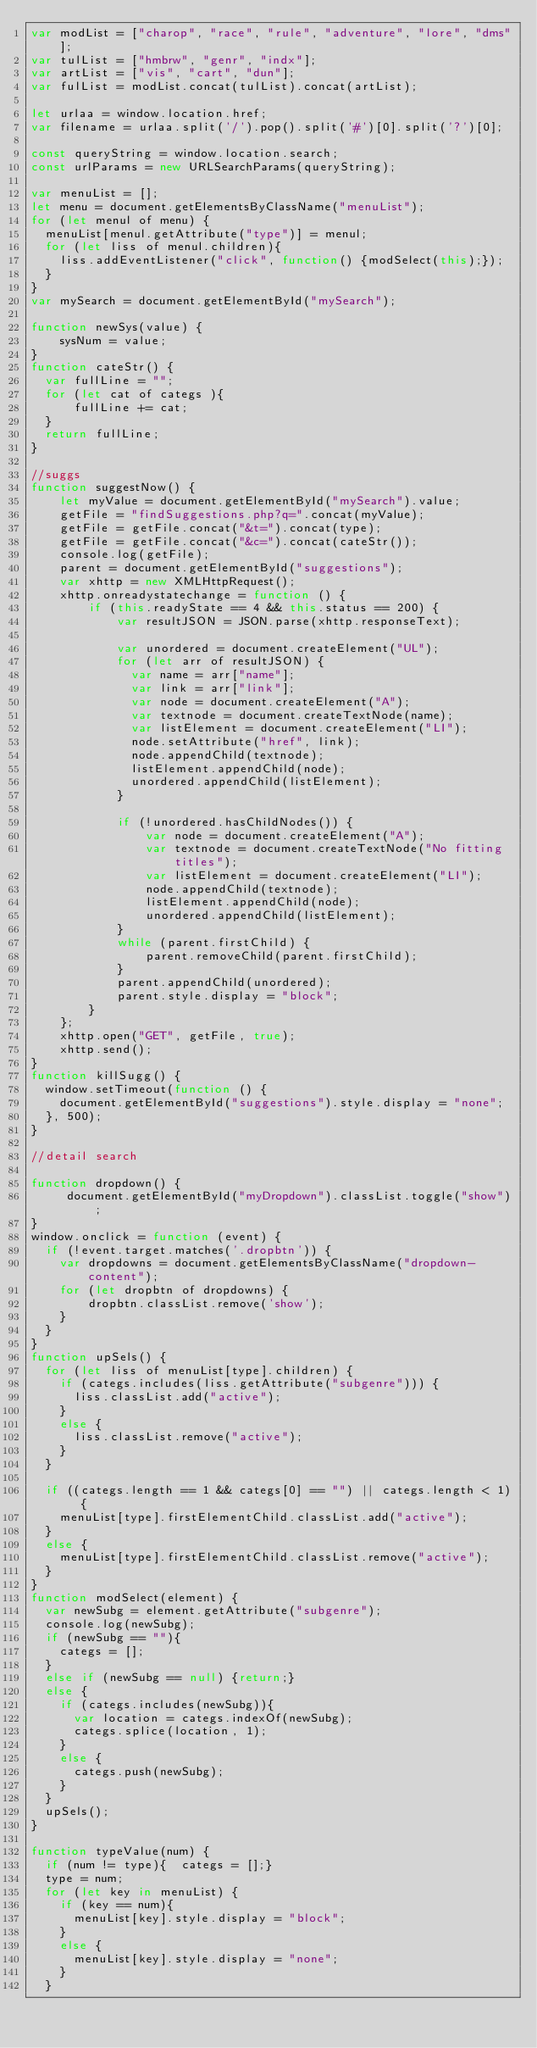<code> <loc_0><loc_0><loc_500><loc_500><_JavaScript_>var modList = ["charop", "race", "rule", "adventure", "lore", "dms"];
var tulList = ["hmbrw", "genr", "indx"];
var artList = ["vis", "cart", "dun"];
var fulList = modList.concat(tulList).concat(artList);

let urlaa = window.location.href;
var filename = urlaa.split('/').pop().split('#')[0].split('?')[0];

const queryString = window.location.search;
const urlParams = new URLSearchParams(queryString);

var menuList = [];
let menu = document.getElementsByClassName("menuList");
for (let menul of menu) {
  menuList[menul.getAttribute("type")] = menul;
  for (let liss of menul.children){
    liss.addEventListener("click", function() {modSelect(this);});
  }
}
var mySearch = document.getElementById("mySearch");

function newSys(value) {
    sysNum = value;
}
function cateStr() {
  var fullLine = "";
  for (let cat of categs ){
      fullLine += cat;
  }
  return fullLine;
}

//suggs
function suggestNow() {
    let myValue = document.getElementById("mySearch").value;
    getFile = "findSuggestions.php?q=".concat(myValue);
    getFile = getFile.concat("&t=").concat(type);
    getFile = getFile.concat("&c=").concat(cateStr());
    console.log(getFile);
    parent = document.getElementById("suggestions");
    var xhttp = new XMLHttpRequest();
    xhttp.onreadystatechange = function () {
        if (this.readyState == 4 && this.status == 200) {
            var resultJSON = JSON.parse(xhttp.responseText);

            var unordered = document.createElement("UL");
            for (let arr of resultJSON) {
              var name = arr["name"];
              var link = arr["link"];
              var node = document.createElement("A");
              var textnode = document.createTextNode(name);
              var listElement = document.createElement("LI");
              node.setAttribute("href", link);
              node.appendChild(textnode);
              listElement.appendChild(node);
              unordered.appendChild(listElement);
            }

            if (!unordered.hasChildNodes()) {
                var node = document.createElement("A");
                var textnode = document.createTextNode("No fitting titles");
                var listElement = document.createElement("LI");
                node.appendChild(textnode);
                listElement.appendChild(node);
                unordered.appendChild(listElement);
            }
            while (parent.firstChild) {
                parent.removeChild(parent.firstChild);
            }
            parent.appendChild(unordered);
            parent.style.display = "block";
        }
    };
    xhttp.open("GET", getFile, true);
    xhttp.send();
}
function killSugg() {
  window.setTimeout(function () {
    document.getElementById("suggestions").style.display = "none";
  }, 500);
}

//detail search

function dropdown() {
     document.getElementById("myDropdown").classList.toggle("show");
}
window.onclick = function (event) {
  if (!event.target.matches('.dropbtn')) {
    var dropdowns = document.getElementsByClassName("dropdown-content");
    for (let dropbtn of dropdowns) {
        dropbtn.classList.remove('show');
    }
  }
}
function upSels() {
  for (let liss of menuList[type].children) {
    if (categs.includes(liss.getAttribute("subgenre"))) {
      liss.classList.add("active");
    }
    else {
      liss.classList.remove("active");
    }
  }

  if ((categs.length == 1 && categs[0] == "") || categs.length < 1) {
    menuList[type].firstElementChild.classList.add("active");
  }
  else {
    menuList[type].firstElementChild.classList.remove("active");
  }
}
function modSelect(element) {
  var newSubg = element.getAttribute("subgenre");
  console.log(newSubg);
  if (newSubg == ""){
    categs = [];
  }
  else if (newSubg == null) {return;}
  else {
    if (categs.includes(newSubg)){
      var location = categs.indexOf(newSubg);
      categs.splice(location, 1);
    }
    else {
      categs.push(newSubg);
    }
  }
  upSels();
}

function typeValue(num) {
  if (num != type){  categs = [];}
  type = num;
  for (let key in menuList) {
    if (key == num){
      menuList[key].style.display = "block";
    }
    else {
      menuList[key].style.display = "none";
    }
  }</code> 